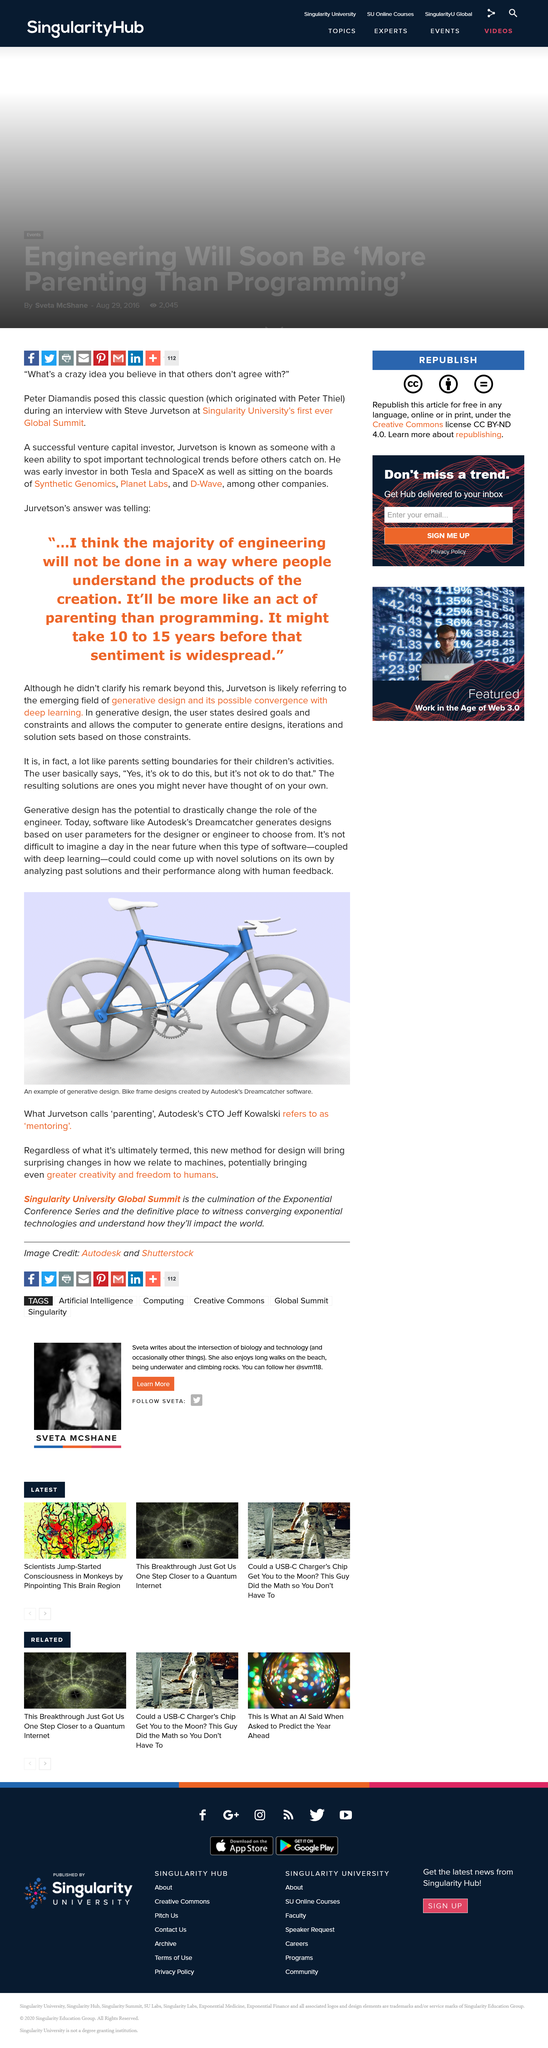Specify some key components in this picture. The picture depicts an example of generative design, which is a type of design that uses algorithms and artificial intelligence to automatically generate designs based on specific criteria. Autodesk's Dreamcatcher software is capable of generating designs based on user parameters. The software created the design shown in the picture is Autodesk's Dreamcatcher software. 